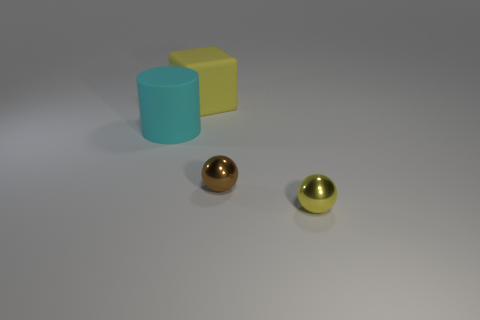Are there any cyan cylinders of the same size as the brown metallic ball?
Offer a very short reply. No. There is a block behind the big matte thing that is in front of the yellow rubber object; is there a tiny brown object that is behind it?
Your answer should be very brief. No. Do the big cylinder and the matte thing that is right of the cylinder have the same color?
Keep it short and to the point. No. There is a tiny object that is right of the metallic thing behind the yellow object in front of the big yellow rubber block; what is it made of?
Your answer should be compact. Metal. The yellow thing that is in front of the big matte cube has what shape?
Provide a succinct answer. Sphere. There is another thing that is the same material as the large cyan object; what is its size?
Offer a very short reply. Large. How many rubber things have the same shape as the tiny brown metallic thing?
Ensure brevity in your answer.  0. There is a small sphere to the left of the tiny yellow ball; does it have the same color as the cube?
Ensure brevity in your answer.  No. There is a metallic sphere that is behind the small sphere in front of the small brown metallic object; what number of brown metallic things are in front of it?
Give a very brief answer. 0. What number of things are both on the right side of the cyan object and to the left of the yellow metallic ball?
Keep it short and to the point. 2. 